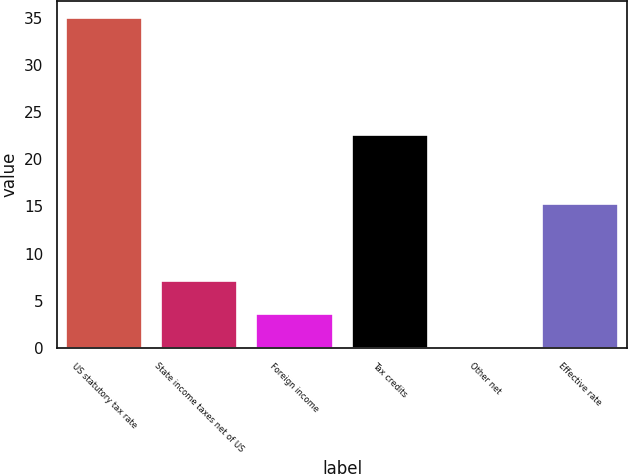<chart> <loc_0><loc_0><loc_500><loc_500><bar_chart><fcel>US statutory tax rate<fcel>State income taxes net of US<fcel>Foreign income<fcel>Tax credits<fcel>Other net<fcel>Effective rate<nl><fcel>35<fcel>7.08<fcel>3.59<fcel>22.6<fcel>0.1<fcel>15.3<nl></chart> 